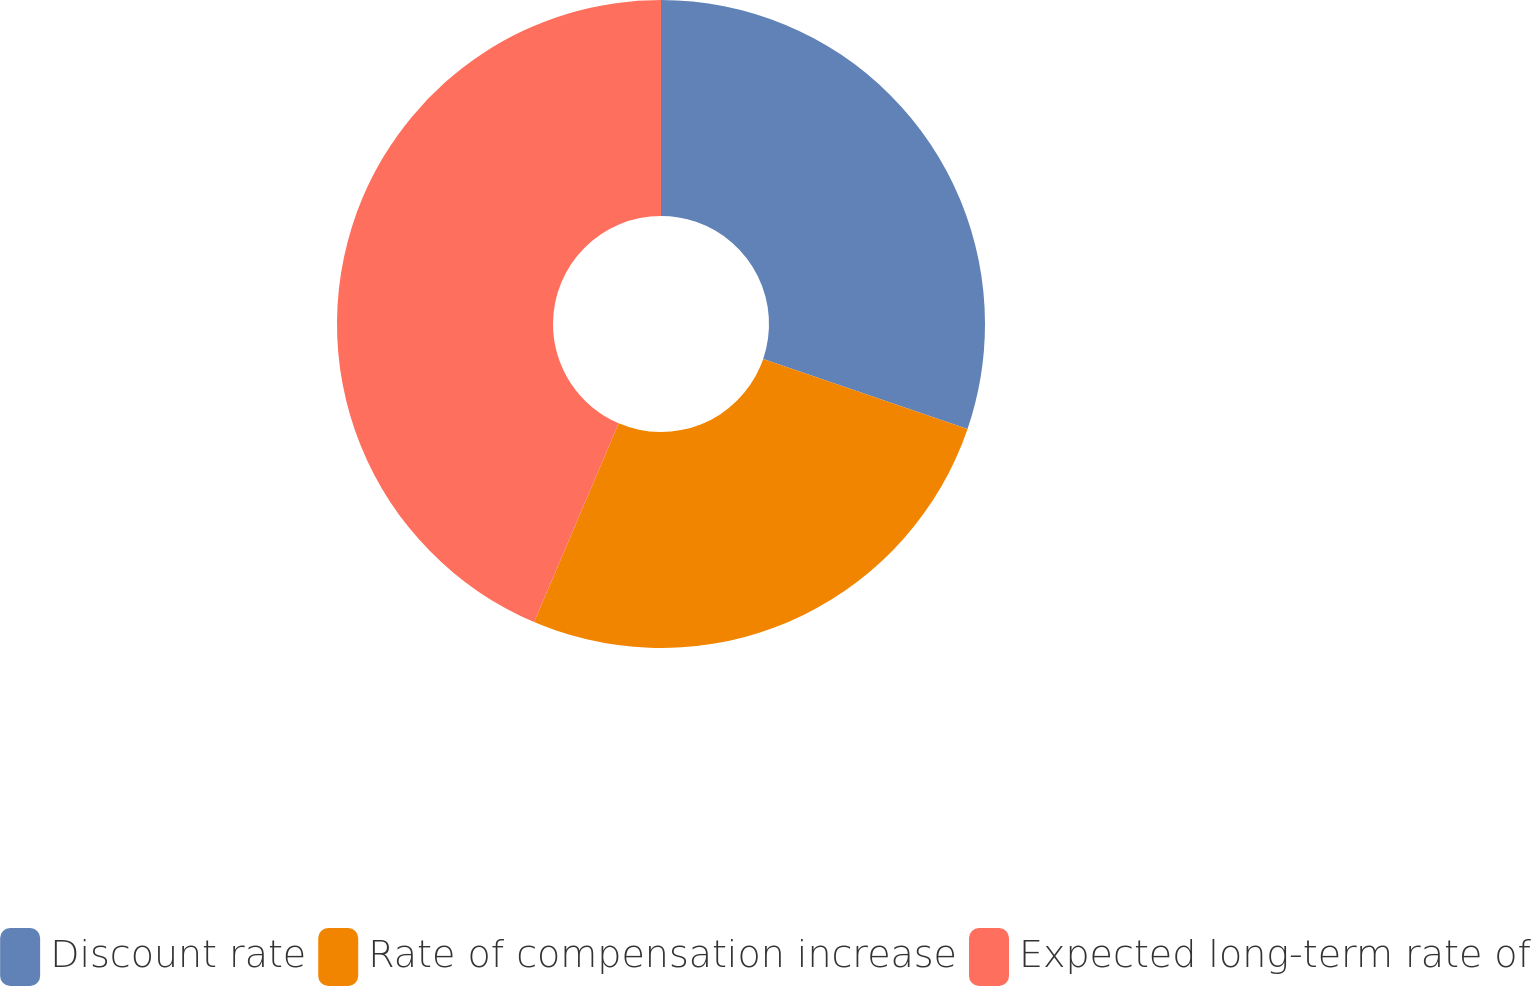<chart> <loc_0><loc_0><loc_500><loc_500><pie_chart><fcel>Discount rate<fcel>Rate of compensation increase<fcel>Expected long-term rate of<nl><fcel>30.25%<fcel>26.16%<fcel>43.6%<nl></chart> 